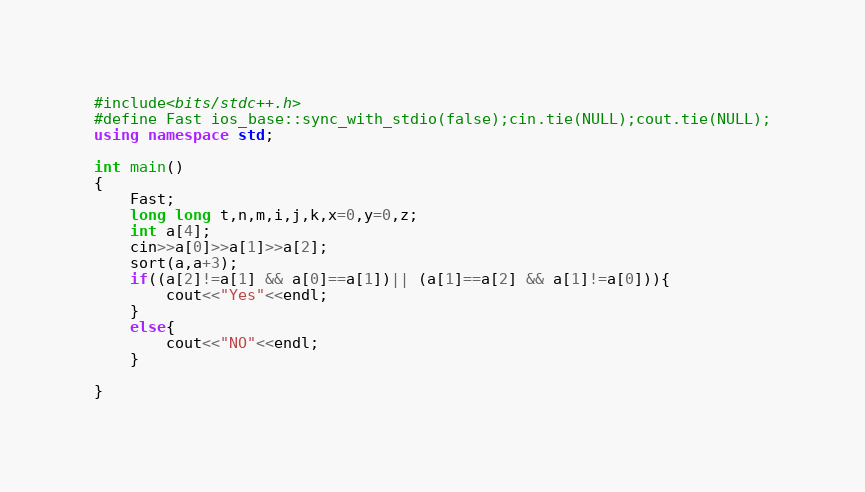Convert code to text. <code><loc_0><loc_0><loc_500><loc_500><_C++_>#include<bits/stdc++.h>
#define Fast ios_base::sync_with_stdio(false);cin.tie(NULL);cout.tie(NULL);
using namespace std;

int main()
{
    Fast;
    long long t,n,m,i,j,k,x=0,y=0,z;
    int a[4];
    cin>>a[0]>>a[1]>>a[2];
    sort(a,a+3);
    if((a[2]!=a[1] && a[0]==a[1])|| (a[1]==a[2] && a[1]!=a[0])){
        cout<<"Yes"<<endl;
    }
    else{
        cout<<"NO"<<endl;
    }

}
</code> 